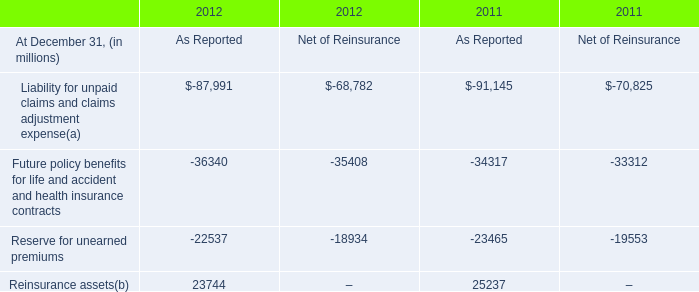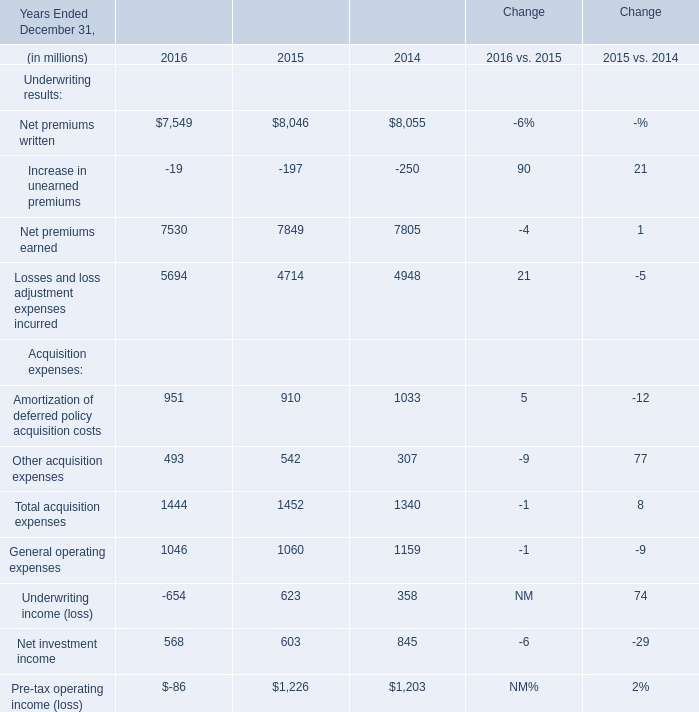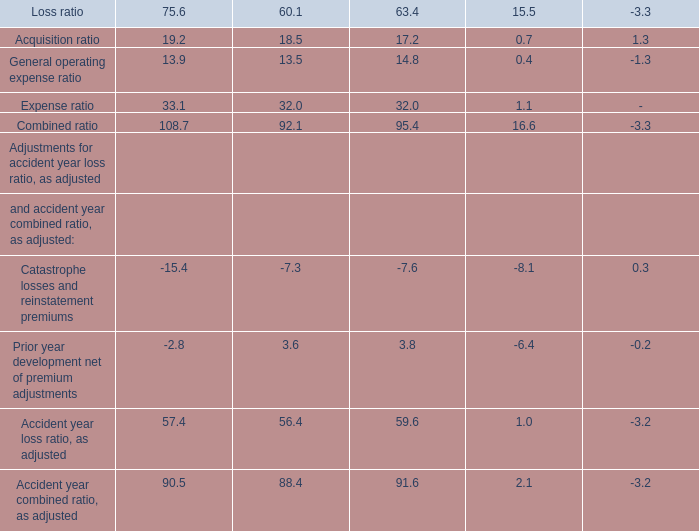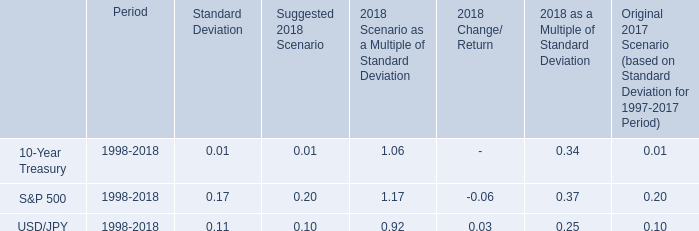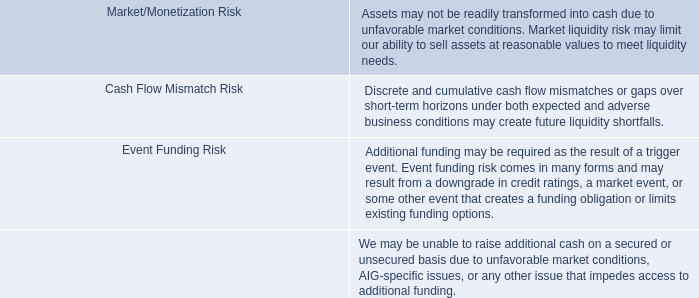In what year is Net premiums written greater than 8050? 
Answer: 2014. 